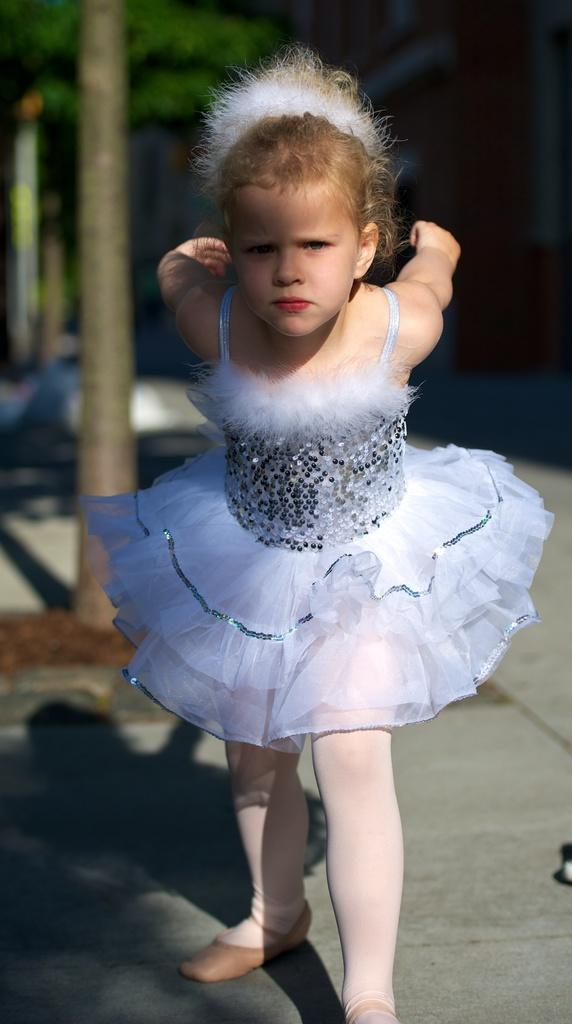Who is the main subject in the image? There is a girl in the image. What is the girl wearing? The girl is wearing a white frock. What can be seen in the background of the image? There is a tree in the background of the image. What else is present in the image besides the girl and the tree? There is a road in the image. What type of basin can be seen in the image? There is no basin present in the image. How many sons are visible in the image? There is no son present in the image; it features a girl. 